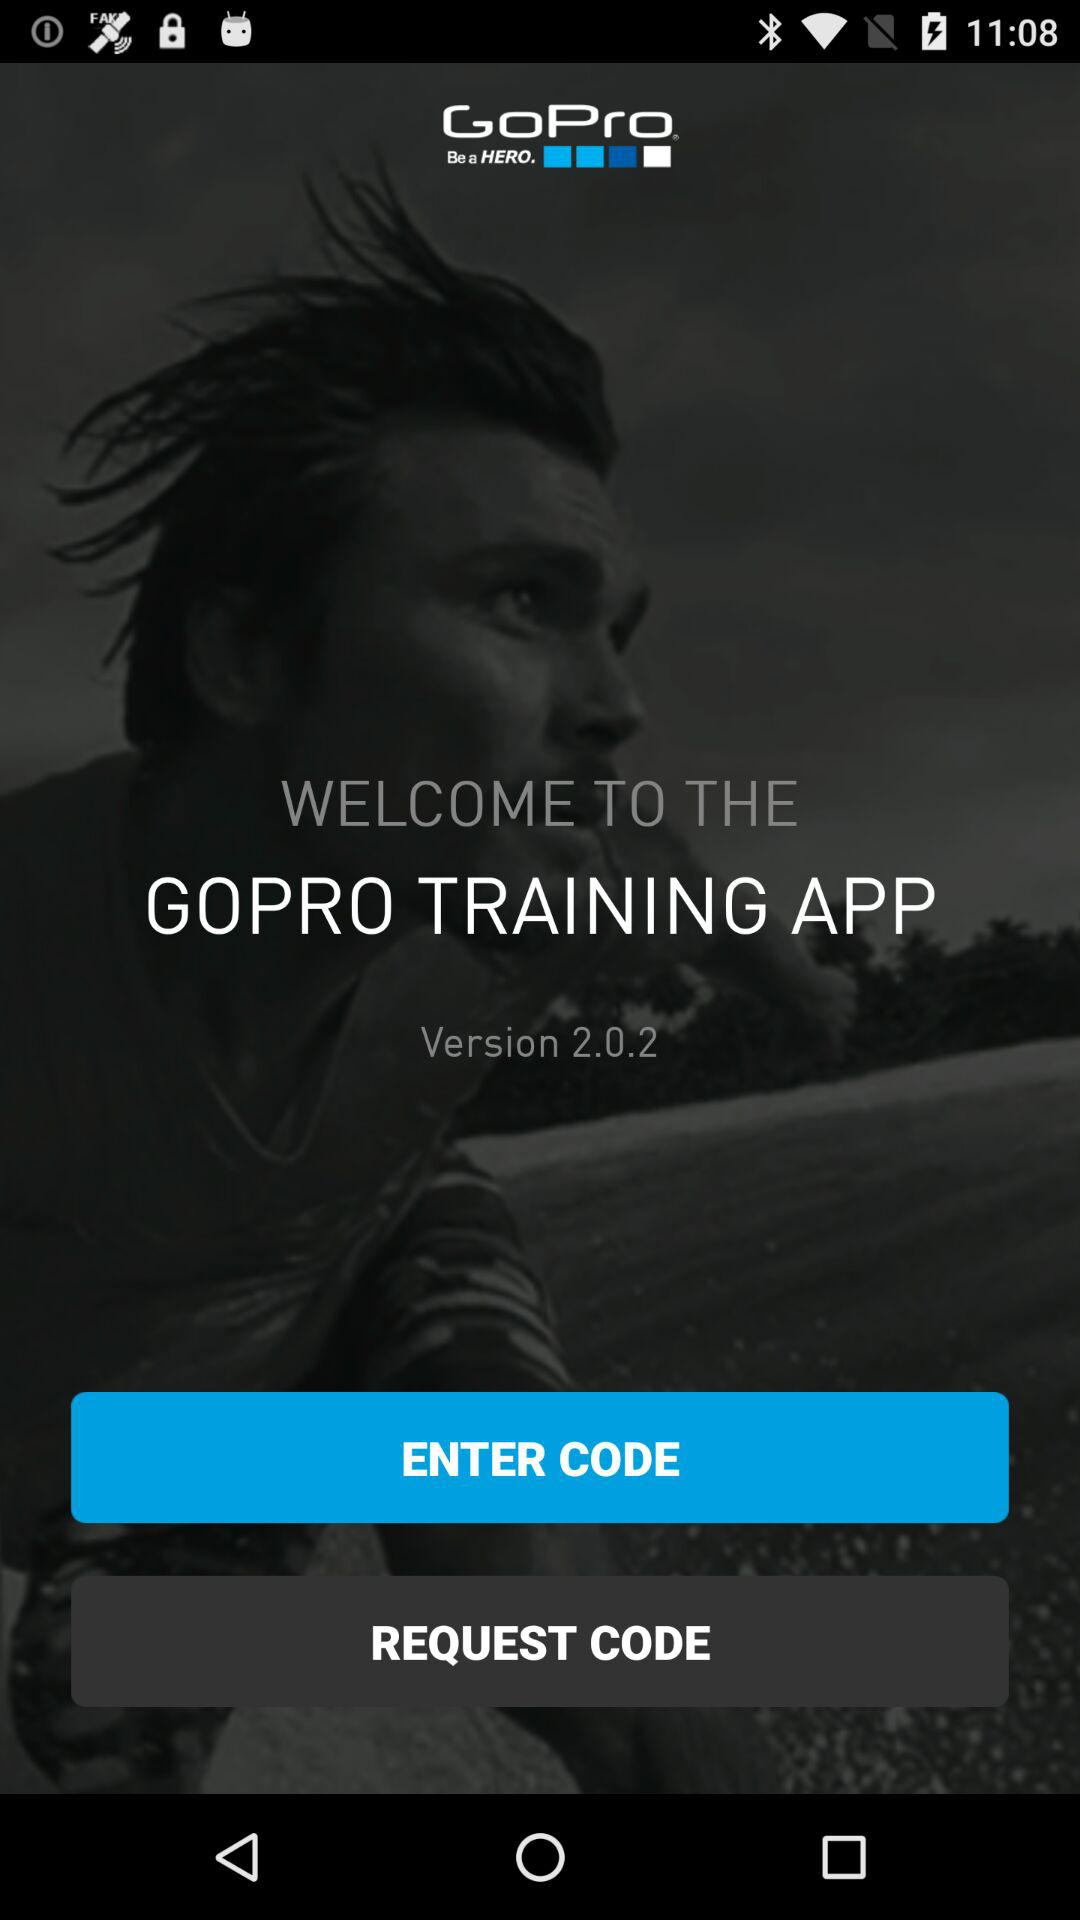What is the name of application? The name of the application is Gopro Training. 